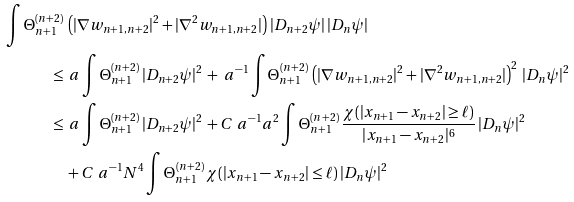<formula> <loc_0><loc_0><loc_500><loc_500>\int \Theta ^ { ( n + 2 ) } _ { n + 1 } \, & \left ( | \nabla w _ { n + 1 , n + 2 } | ^ { 2 } + | \nabla ^ { 2 } w _ { n + 1 , n + 2 } | \right ) \, | D _ { n + 2 } \psi | \, | D _ { n } \psi | \\ \leq \, & \ a \int \Theta ^ { ( n + 2 ) } _ { n + 1 } \, | D _ { n + 2 } \psi | ^ { 2 } \, + \ a ^ { - 1 } \int \Theta ^ { ( n + 2 ) } _ { n + 1 } \, \left ( | \nabla w _ { n + 1 , n + 2 } | ^ { 2 } + | \nabla ^ { 2 } w _ { n + 1 , n + 2 } | \right ) ^ { 2 } \, | D _ { n } \psi | ^ { 2 } \\ \leq \, & \ a \int \Theta ^ { ( n + 2 ) } _ { n + 1 } \, | D _ { n + 2 } \psi | ^ { 2 } \, + C \ a ^ { - 1 } a ^ { 2 } \int \Theta ^ { ( n + 2 ) } _ { n + 1 } \, \frac { \chi ( | x _ { n + 1 } - x _ { n + 2 } | \geq \ell ) } { | x _ { n + 1 } - x _ { n + 2 } | ^ { 6 } } \, | D _ { n } \psi | ^ { 2 } \\ & + C \ a ^ { - 1 } N ^ { 4 } \int \Theta ^ { ( n + 2 ) } _ { n + 1 } \, \chi ( | x _ { n + 1 } - x _ { n + 2 } | \leq \ell ) \, | D _ { n } \psi | ^ { 2 }</formula> 